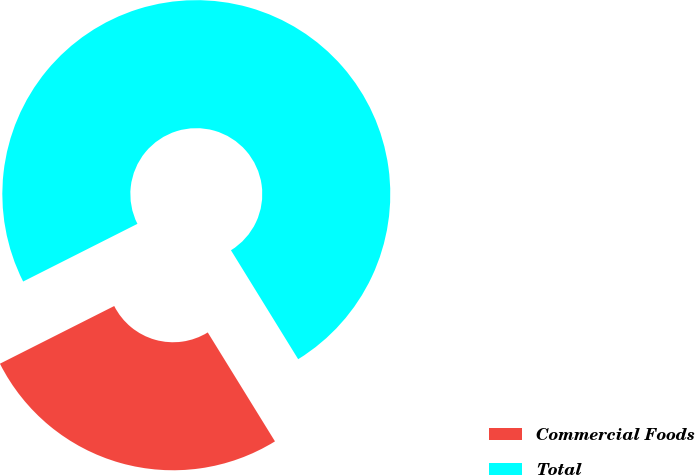<chart> <loc_0><loc_0><loc_500><loc_500><pie_chart><fcel>Commercial Foods<fcel>Total<nl><fcel>26.36%<fcel>73.64%<nl></chart> 